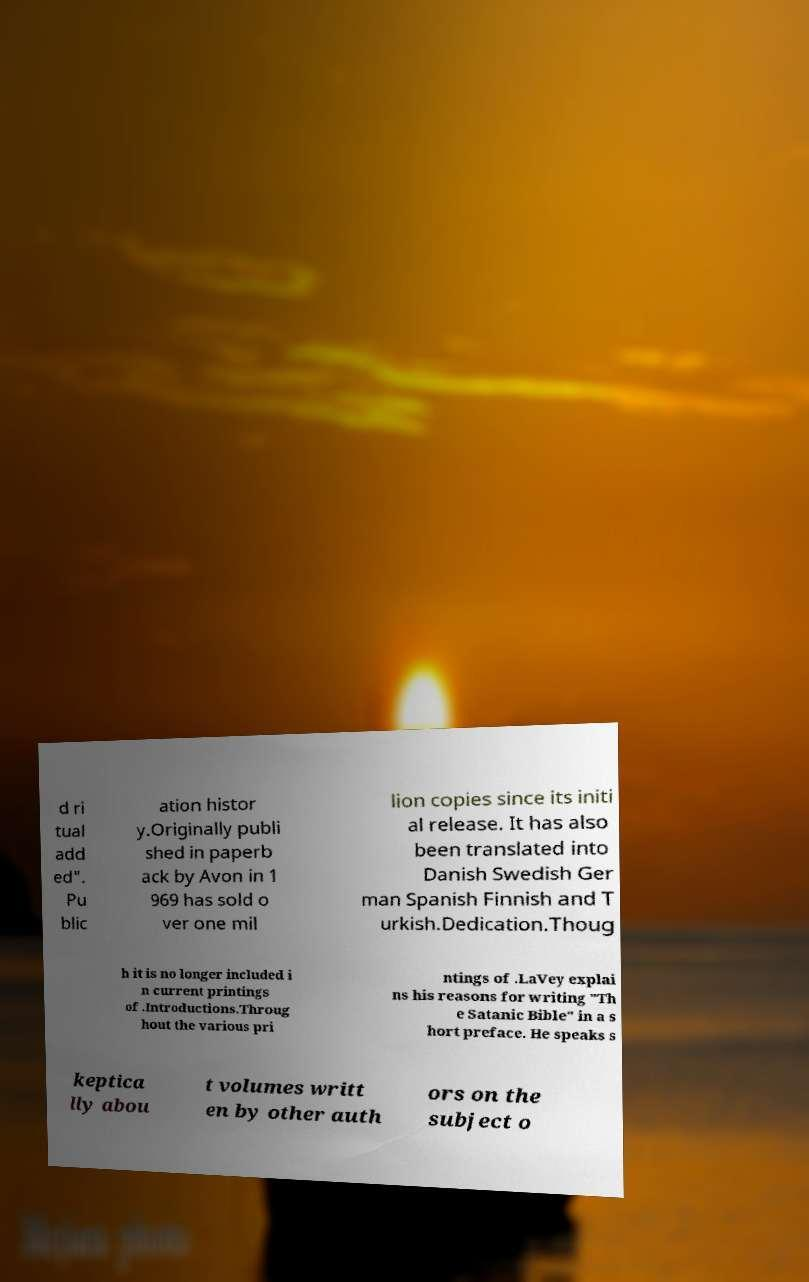For documentation purposes, I need the text within this image transcribed. Could you provide that? d ri tual add ed". Pu blic ation histor y.Originally publi shed in paperb ack by Avon in 1 969 has sold o ver one mil lion copies since its initi al release. It has also been translated into Danish Swedish Ger man Spanish Finnish and T urkish.Dedication.Thoug h it is no longer included i n current printings of .Introductions.Throug hout the various pri ntings of .LaVey explai ns his reasons for writing "Th e Satanic Bible" in a s hort preface. He speaks s keptica lly abou t volumes writt en by other auth ors on the subject o 